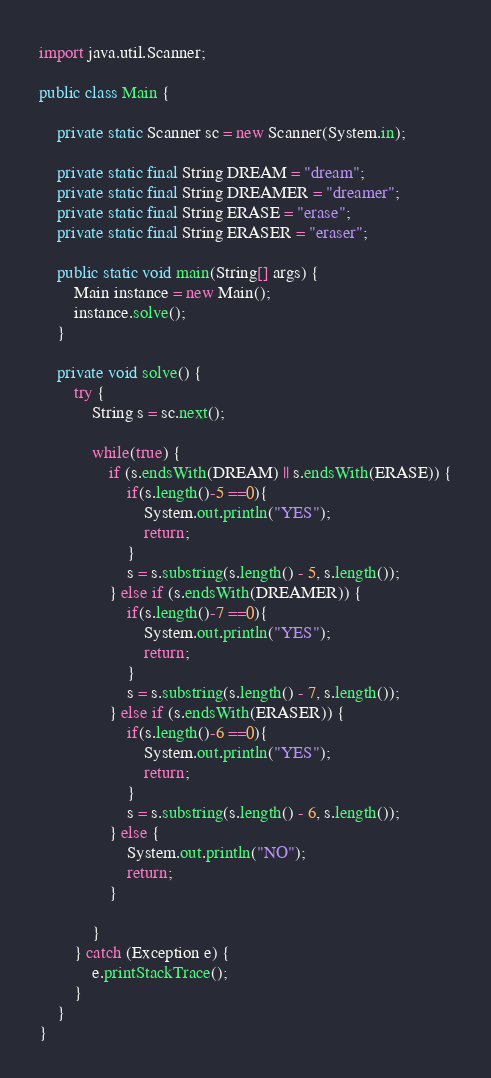<code> <loc_0><loc_0><loc_500><loc_500><_Java_>import java.util.Scanner;

public class Main {

    private static Scanner sc = new Scanner(System.in);

    private static final String DREAM = "dream";
    private static final String DREAMER = "dreamer";
    private static final String ERASE = "erase";
    private static final String ERASER = "eraser";

    public static void main(String[] args) {
        Main instance = new Main();
        instance.solve();
    }

    private void solve() {
        try {
            String s = sc.next();

            while(true) {
                if (s.endsWith(DREAM) || s.endsWith(ERASE)) {
                    if(s.length()-5 ==0){
                        System.out.println("YES");
                        return;
                    }
                    s = s.substring(s.length() - 5, s.length());
                } else if (s.endsWith(DREAMER)) {
                    if(s.length()-7 ==0){
                        System.out.println("YES");
                        return;
                    }
                    s = s.substring(s.length() - 7, s.length());
                } else if (s.endsWith(ERASER)) {
                    if(s.length()-6 ==0){
                        System.out.println("YES");
                        return;
                    }
                    s = s.substring(s.length() - 6, s.length());
                } else {
                    System.out.println("NO");
                    return;
                }

            }
        } catch (Exception e) {
            e.printStackTrace();
        }
    }
}</code> 